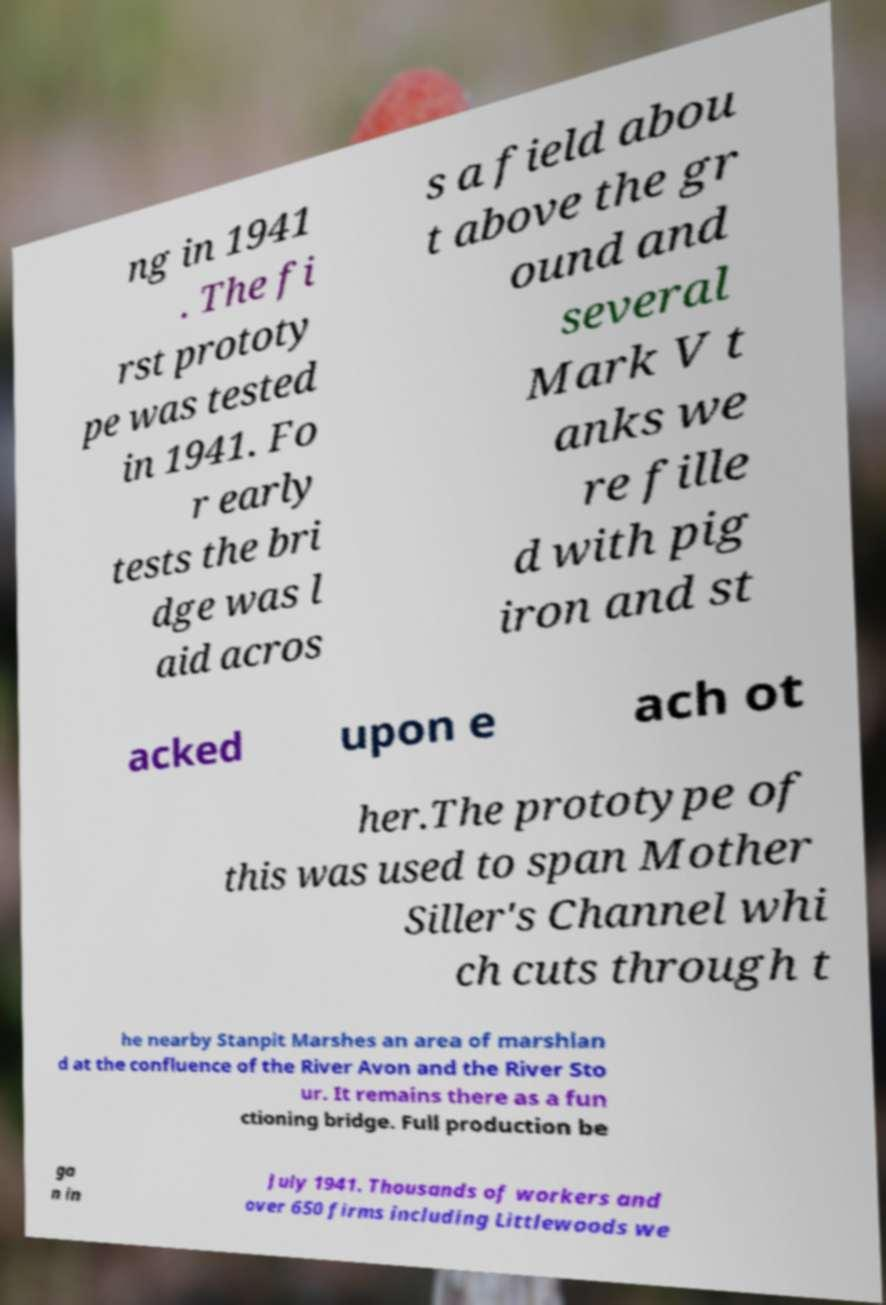Please read and relay the text visible in this image. What does it say? ng in 1941 . The fi rst prototy pe was tested in 1941. Fo r early tests the bri dge was l aid acros s a field abou t above the gr ound and several Mark V t anks we re fille d with pig iron and st acked upon e ach ot her.The prototype of this was used to span Mother Siller's Channel whi ch cuts through t he nearby Stanpit Marshes an area of marshlan d at the confluence of the River Avon and the River Sto ur. It remains there as a fun ctioning bridge. Full production be ga n in July 1941. Thousands of workers and over 650 firms including Littlewoods we 